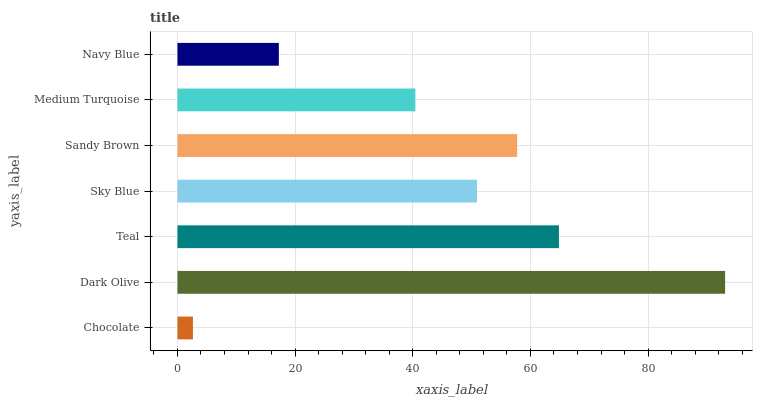Is Chocolate the minimum?
Answer yes or no. Yes. Is Dark Olive the maximum?
Answer yes or no. Yes. Is Teal the minimum?
Answer yes or no. No. Is Teal the maximum?
Answer yes or no. No. Is Dark Olive greater than Teal?
Answer yes or no. Yes. Is Teal less than Dark Olive?
Answer yes or no. Yes. Is Teal greater than Dark Olive?
Answer yes or no. No. Is Dark Olive less than Teal?
Answer yes or no. No. Is Sky Blue the high median?
Answer yes or no. Yes. Is Sky Blue the low median?
Answer yes or no. Yes. Is Teal the high median?
Answer yes or no. No. Is Teal the low median?
Answer yes or no. No. 